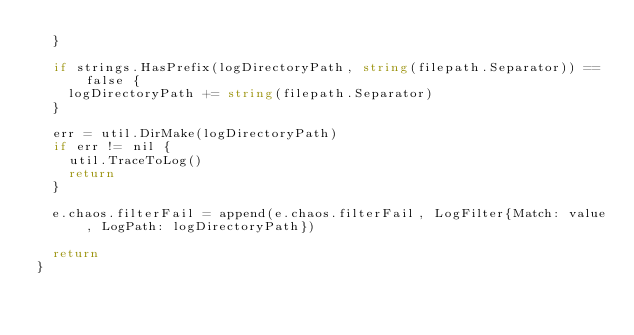Convert code to text. <code><loc_0><loc_0><loc_500><loc_500><_Go_>	}

	if strings.HasPrefix(logDirectoryPath, string(filepath.Separator)) == false {
		logDirectoryPath += string(filepath.Separator)
	}

	err = util.DirMake(logDirectoryPath)
	if err != nil {
		util.TraceToLog()
		return
	}

	e.chaos.filterFail = append(e.chaos.filterFail, LogFilter{Match: value, LogPath: logDirectoryPath})

	return
}
</code> 